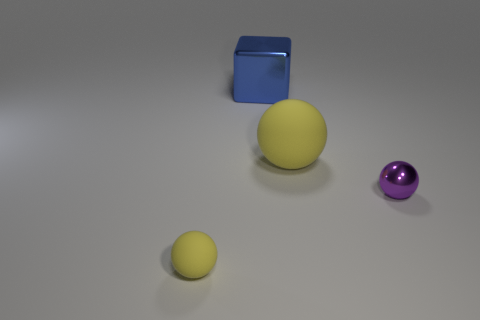What number of big yellow rubber balls are in front of the large sphere?
Offer a terse response. 0. How big is the blue metal block?
Provide a short and direct response. Large. Are the yellow sphere that is on the right side of the blue object and the small sphere that is in front of the tiny purple object made of the same material?
Your answer should be very brief. Yes. Are there any big metallic blocks that have the same color as the big metal object?
Your answer should be compact. No. The object that is the same size as the purple metal sphere is what color?
Your answer should be very brief. Yellow. There is a metal object on the left side of the purple thing; is its color the same as the big sphere?
Provide a short and direct response. No. Are there any tiny purple balls made of the same material as the purple thing?
Keep it short and to the point. No. The tiny matte thing that is the same color as the large matte object is what shape?
Give a very brief answer. Sphere. Are there fewer tiny yellow things that are right of the big shiny cube than tiny objects?
Keep it short and to the point. Yes. There is a yellow matte sphere that is left of the shiny cube; is its size the same as the big shiny thing?
Offer a very short reply. No. 